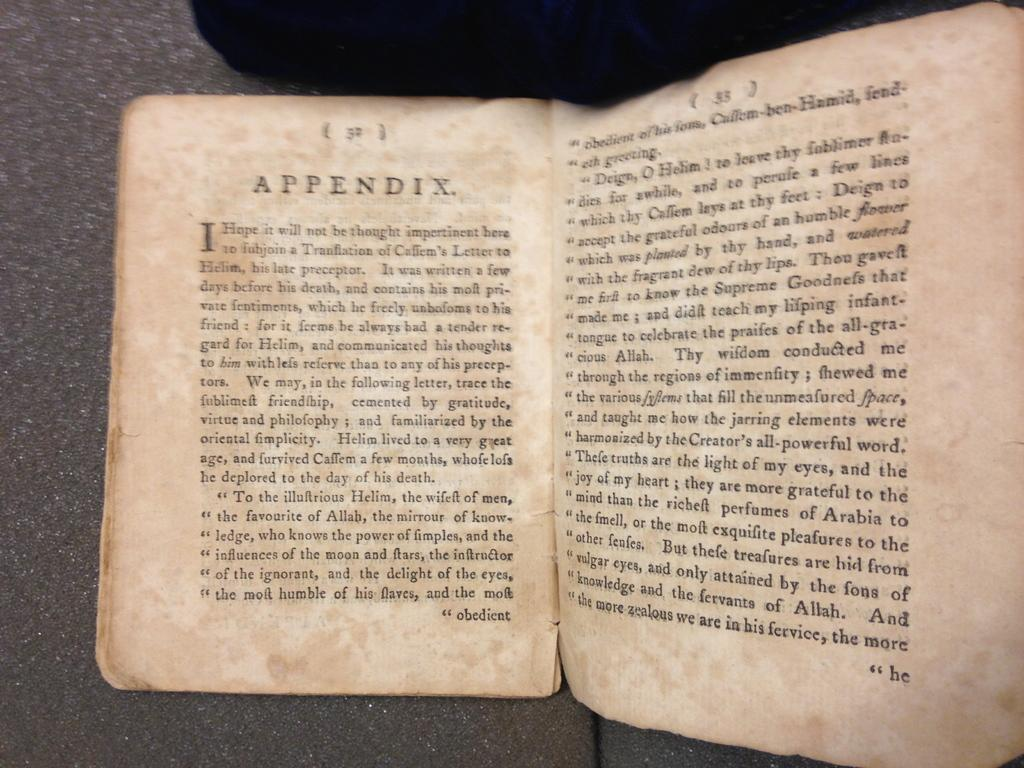<image>
Give a short and clear explanation of the subsequent image. A book is open to the appendix, which starts on page 32. 